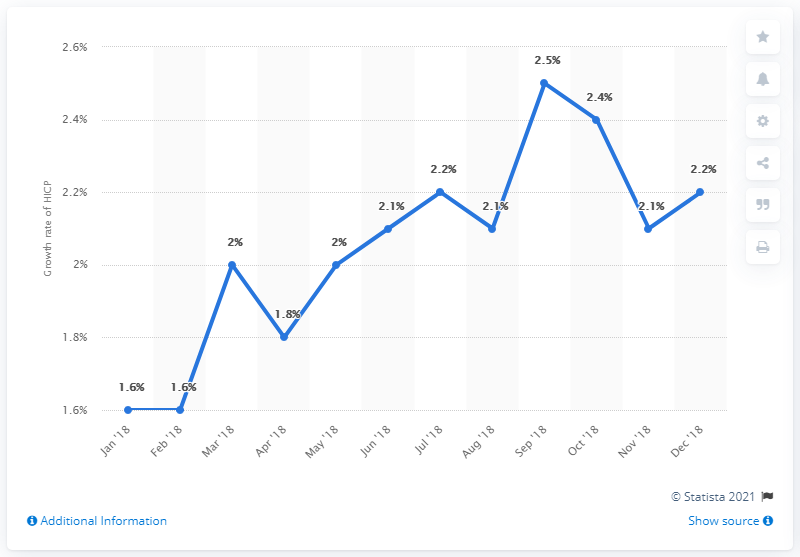Point out several critical features in this image. The inflation rate in December 2018 was 2.2%. As of August 2018, the rate was 2.1. The mode is a measure of central tendency that is used to identify the value that occurs most frequently in a dataset. For example, if a dataset contains the following numbers: 2.1, 3.4, 2.1, 4.9, 2.1, 2.1, the mode would be 2.1 because it is the value that occurs most frequently in the dataset. 